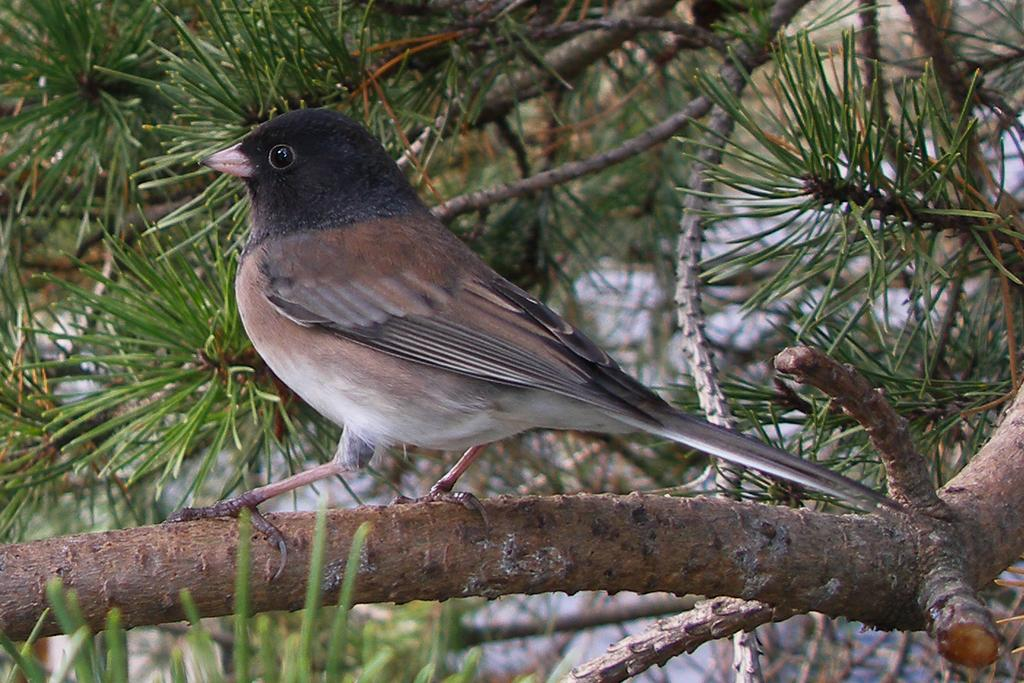What animal can be seen in the image? There is a bird in the image. Where is the bird located? The bird is standing on a branch. What is the branch connected to? The branch is from a tree. What is the appearance of the tree's leaves? The tree has green color leaves. What can be seen in the background of the image? There are other trees in the background of the image. What type of dust can be seen on the bird's feathers in the image? There is no dust visible on the bird's feathers in the image. 